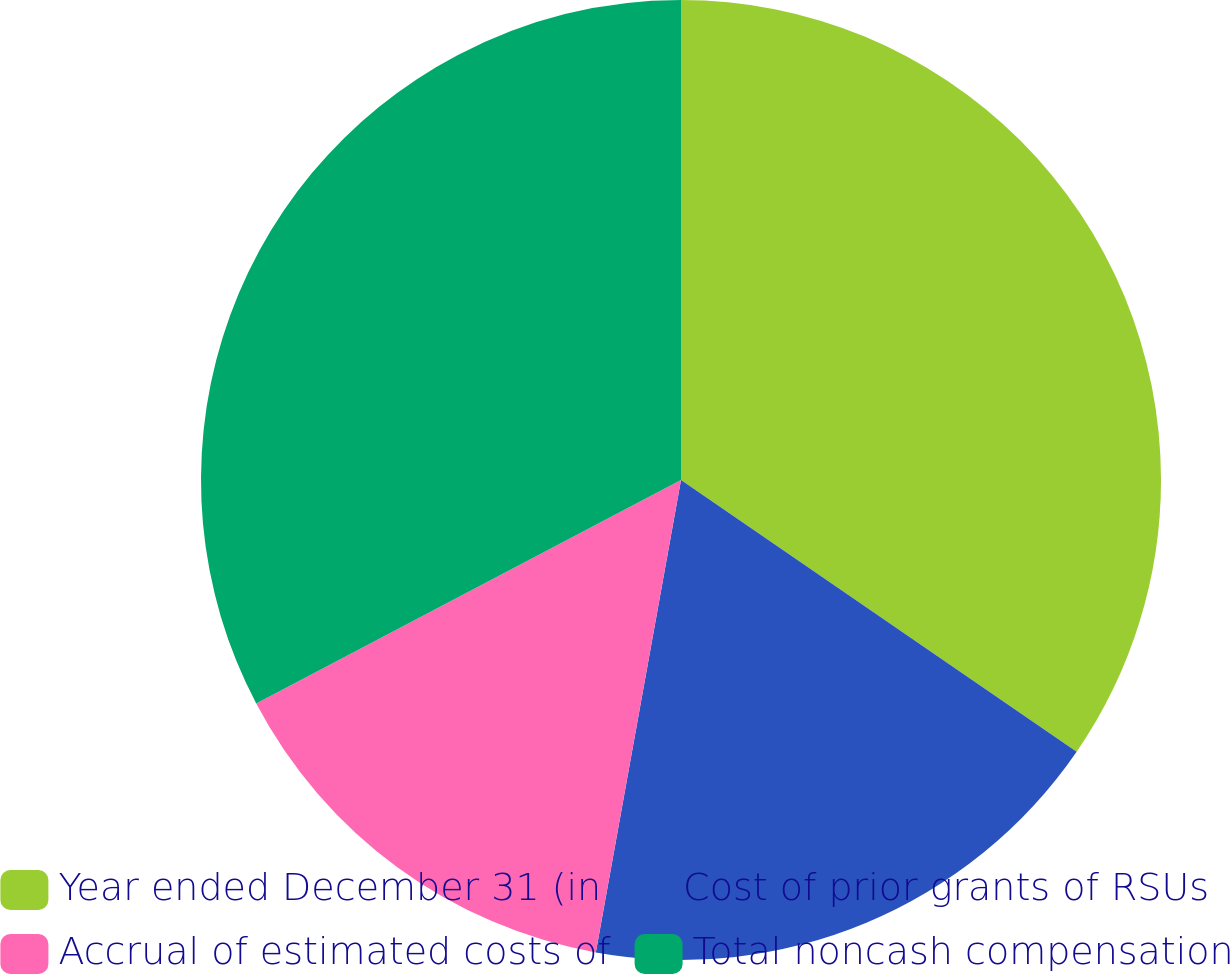Convert chart. <chart><loc_0><loc_0><loc_500><loc_500><pie_chart><fcel>Year ended December 31 (in<fcel>Cost of prior grants of RSUs<fcel>Accrual of estimated costs of<fcel>Total noncash compensation<nl><fcel>34.58%<fcel>18.26%<fcel>14.45%<fcel>32.71%<nl></chart> 